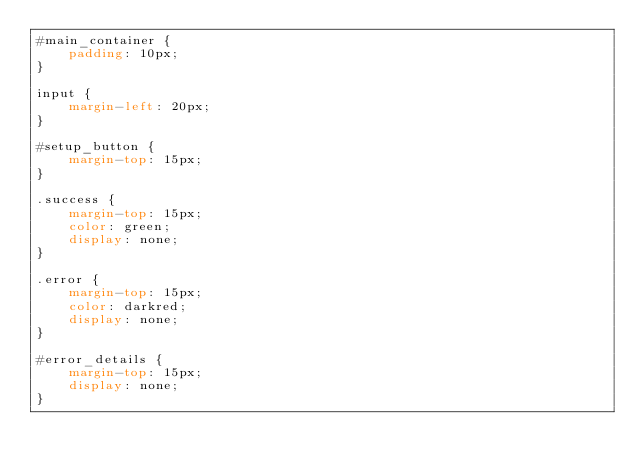<code> <loc_0><loc_0><loc_500><loc_500><_CSS_>#main_container {
    padding: 10px;
}

input {
    margin-left: 20px;
}

#setup_button {
    margin-top: 15px;
}

.success {
    margin-top: 15px;
    color: green;
    display: none;
}

.error {
    margin-top: 15px;
    color: darkred;
    display: none;
}

#error_details {
    margin-top: 15px;
    display: none;
}</code> 